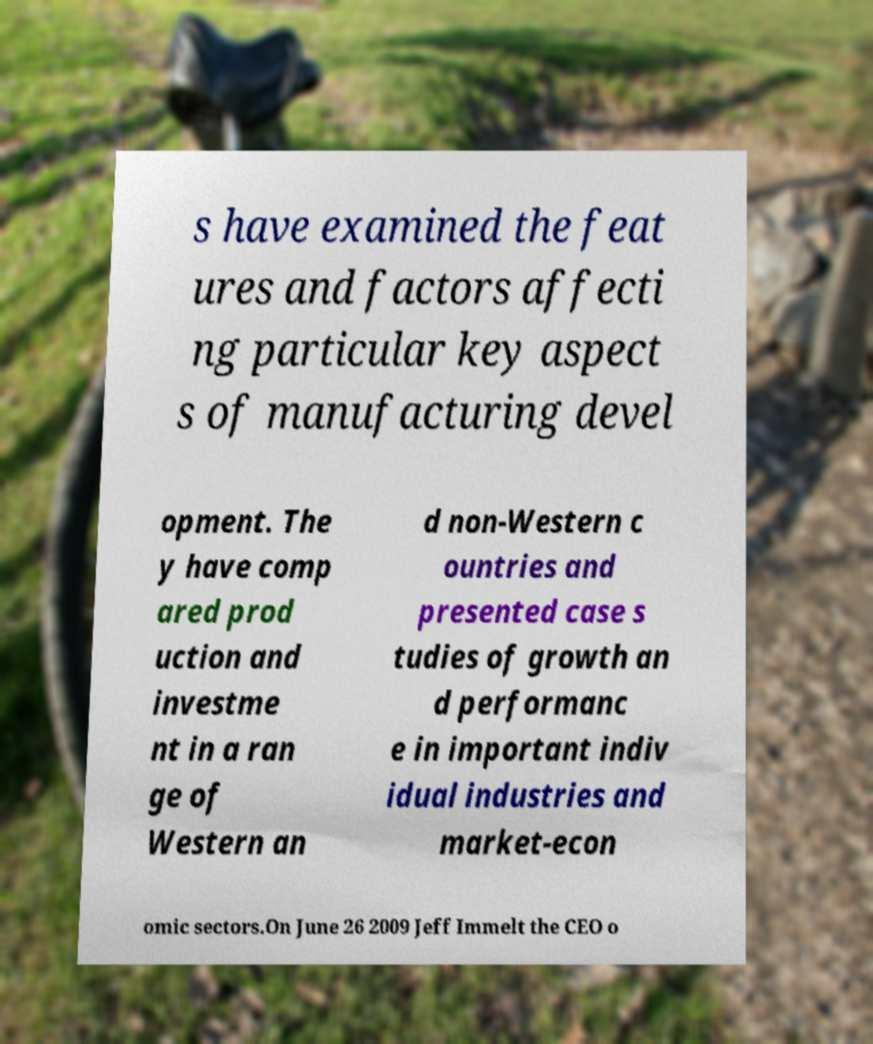What messages or text are displayed in this image? I need them in a readable, typed format. s have examined the feat ures and factors affecti ng particular key aspect s of manufacturing devel opment. The y have comp ared prod uction and investme nt in a ran ge of Western an d non-Western c ountries and presented case s tudies of growth an d performanc e in important indiv idual industries and market-econ omic sectors.On June 26 2009 Jeff Immelt the CEO o 